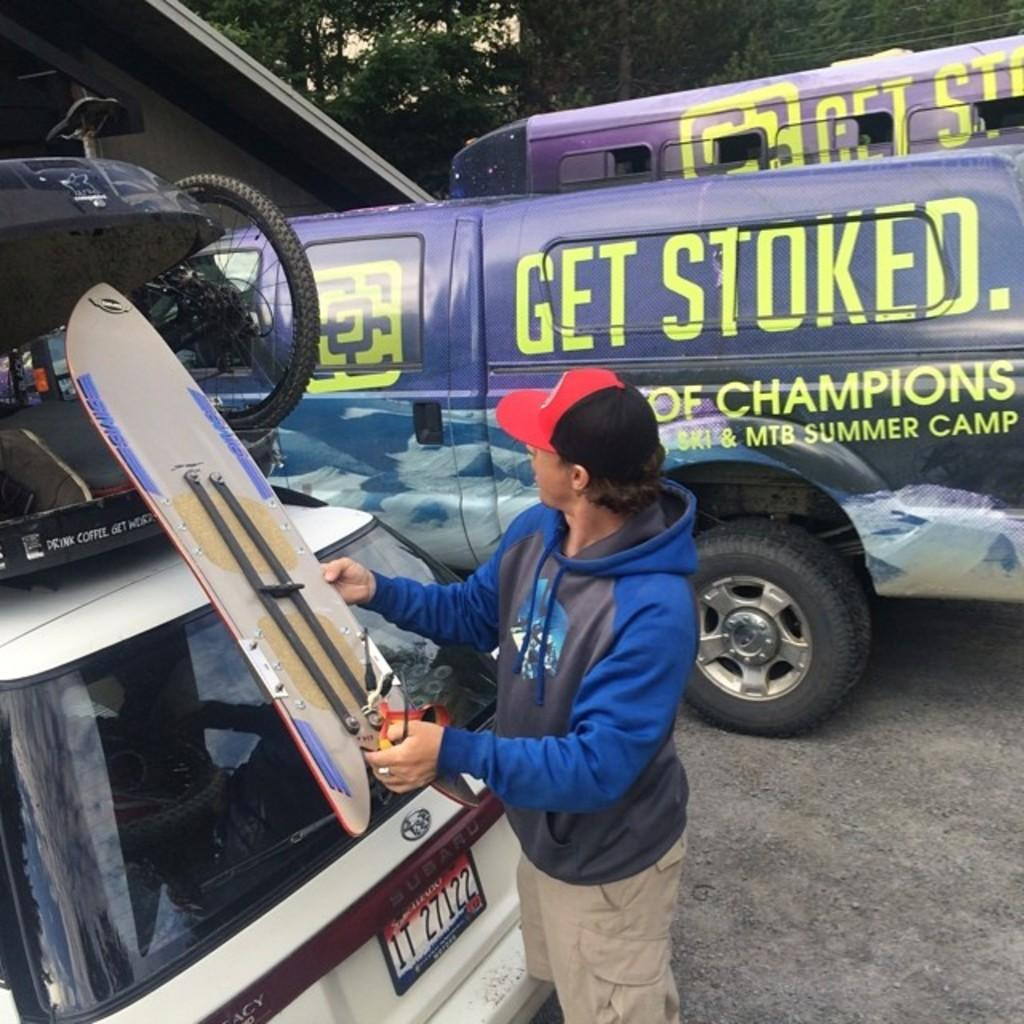What is the person in the image doing? The person is holding a board in the image. Where is the person standing in relation to the car? The person is standing beside a car in the image. What other large vehicle can be seen in the image? There is another big vehicle in the image. What type of natural elements are present in the image? Trees are present in the image. What taste does the chalk have in the image? There is no chalk present in the image, so it is not possible to determine its taste. 